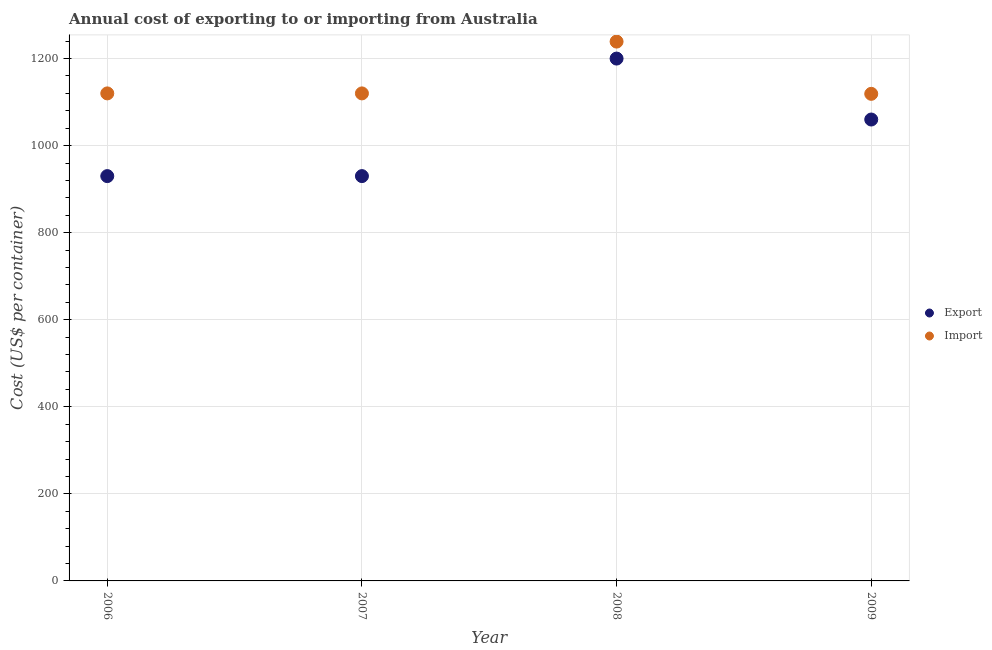What is the import cost in 2008?
Ensure brevity in your answer.  1239. Across all years, what is the maximum import cost?
Ensure brevity in your answer.  1239. Across all years, what is the minimum import cost?
Give a very brief answer. 1119. In which year was the import cost maximum?
Make the answer very short. 2008. In which year was the import cost minimum?
Provide a short and direct response. 2009. What is the total import cost in the graph?
Provide a short and direct response. 4598. What is the difference between the import cost in 2007 and that in 2008?
Offer a very short reply. -119. What is the difference between the import cost in 2007 and the export cost in 2009?
Ensure brevity in your answer.  60. What is the average export cost per year?
Give a very brief answer. 1030. In the year 2008, what is the difference between the export cost and import cost?
Offer a terse response. -39. What is the ratio of the export cost in 2006 to that in 2009?
Your answer should be compact. 0.88. Is the export cost in 2007 less than that in 2008?
Provide a succinct answer. Yes. What is the difference between the highest and the second highest import cost?
Your answer should be compact. 119. What is the difference between the highest and the lowest export cost?
Give a very brief answer. 270. Is the import cost strictly less than the export cost over the years?
Provide a succinct answer. No. How many dotlines are there?
Your response must be concise. 2. How many years are there in the graph?
Give a very brief answer. 4. Does the graph contain any zero values?
Your answer should be compact. No. Where does the legend appear in the graph?
Offer a terse response. Center right. How are the legend labels stacked?
Give a very brief answer. Vertical. What is the title of the graph?
Provide a short and direct response. Annual cost of exporting to or importing from Australia. Does "Residents" appear as one of the legend labels in the graph?
Ensure brevity in your answer.  No. What is the label or title of the X-axis?
Give a very brief answer. Year. What is the label or title of the Y-axis?
Offer a very short reply. Cost (US$ per container). What is the Cost (US$ per container) of Export in 2006?
Your answer should be very brief. 930. What is the Cost (US$ per container) of Import in 2006?
Ensure brevity in your answer.  1120. What is the Cost (US$ per container) of Export in 2007?
Offer a very short reply. 930. What is the Cost (US$ per container) of Import in 2007?
Your answer should be very brief. 1120. What is the Cost (US$ per container) in Export in 2008?
Offer a very short reply. 1200. What is the Cost (US$ per container) in Import in 2008?
Your answer should be compact. 1239. What is the Cost (US$ per container) in Export in 2009?
Offer a terse response. 1060. What is the Cost (US$ per container) of Import in 2009?
Give a very brief answer. 1119. Across all years, what is the maximum Cost (US$ per container) of Export?
Your answer should be compact. 1200. Across all years, what is the maximum Cost (US$ per container) of Import?
Your response must be concise. 1239. Across all years, what is the minimum Cost (US$ per container) of Export?
Your answer should be very brief. 930. Across all years, what is the minimum Cost (US$ per container) in Import?
Provide a short and direct response. 1119. What is the total Cost (US$ per container) in Export in the graph?
Make the answer very short. 4120. What is the total Cost (US$ per container) of Import in the graph?
Your answer should be compact. 4598. What is the difference between the Cost (US$ per container) of Export in 2006 and that in 2008?
Make the answer very short. -270. What is the difference between the Cost (US$ per container) in Import in 2006 and that in 2008?
Your answer should be very brief. -119. What is the difference between the Cost (US$ per container) of Export in 2006 and that in 2009?
Make the answer very short. -130. What is the difference between the Cost (US$ per container) of Export in 2007 and that in 2008?
Make the answer very short. -270. What is the difference between the Cost (US$ per container) of Import in 2007 and that in 2008?
Provide a short and direct response. -119. What is the difference between the Cost (US$ per container) in Export in 2007 and that in 2009?
Provide a succinct answer. -130. What is the difference between the Cost (US$ per container) in Import in 2007 and that in 2009?
Your answer should be very brief. 1. What is the difference between the Cost (US$ per container) in Export in 2008 and that in 2009?
Provide a short and direct response. 140. What is the difference between the Cost (US$ per container) in Import in 2008 and that in 2009?
Your answer should be very brief. 120. What is the difference between the Cost (US$ per container) in Export in 2006 and the Cost (US$ per container) in Import in 2007?
Provide a short and direct response. -190. What is the difference between the Cost (US$ per container) of Export in 2006 and the Cost (US$ per container) of Import in 2008?
Make the answer very short. -309. What is the difference between the Cost (US$ per container) in Export in 2006 and the Cost (US$ per container) in Import in 2009?
Give a very brief answer. -189. What is the difference between the Cost (US$ per container) of Export in 2007 and the Cost (US$ per container) of Import in 2008?
Keep it short and to the point. -309. What is the difference between the Cost (US$ per container) in Export in 2007 and the Cost (US$ per container) in Import in 2009?
Provide a succinct answer. -189. What is the average Cost (US$ per container) of Export per year?
Your answer should be very brief. 1030. What is the average Cost (US$ per container) of Import per year?
Make the answer very short. 1149.5. In the year 2006, what is the difference between the Cost (US$ per container) in Export and Cost (US$ per container) in Import?
Your answer should be very brief. -190. In the year 2007, what is the difference between the Cost (US$ per container) of Export and Cost (US$ per container) of Import?
Your response must be concise. -190. In the year 2008, what is the difference between the Cost (US$ per container) of Export and Cost (US$ per container) of Import?
Make the answer very short. -39. In the year 2009, what is the difference between the Cost (US$ per container) in Export and Cost (US$ per container) in Import?
Offer a very short reply. -59. What is the ratio of the Cost (US$ per container) of Export in 2006 to that in 2007?
Keep it short and to the point. 1. What is the ratio of the Cost (US$ per container) of Export in 2006 to that in 2008?
Offer a very short reply. 0.78. What is the ratio of the Cost (US$ per container) in Import in 2006 to that in 2008?
Make the answer very short. 0.9. What is the ratio of the Cost (US$ per container) in Export in 2006 to that in 2009?
Offer a very short reply. 0.88. What is the ratio of the Cost (US$ per container) in Import in 2006 to that in 2009?
Give a very brief answer. 1. What is the ratio of the Cost (US$ per container) in Export in 2007 to that in 2008?
Your answer should be very brief. 0.78. What is the ratio of the Cost (US$ per container) in Import in 2007 to that in 2008?
Make the answer very short. 0.9. What is the ratio of the Cost (US$ per container) of Export in 2007 to that in 2009?
Offer a terse response. 0.88. What is the ratio of the Cost (US$ per container) in Export in 2008 to that in 2009?
Offer a very short reply. 1.13. What is the ratio of the Cost (US$ per container) of Import in 2008 to that in 2009?
Offer a very short reply. 1.11. What is the difference between the highest and the second highest Cost (US$ per container) of Export?
Provide a succinct answer. 140. What is the difference between the highest and the second highest Cost (US$ per container) of Import?
Provide a short and direct response. 119. What is the difference between the highest and the lowest Cost (US$ per container) of Export?
Provide a short and direct response. 270. What is the difference between the highest and the lowest Cost (US$ per container) of Import?
Offer a very short reply. 120. 